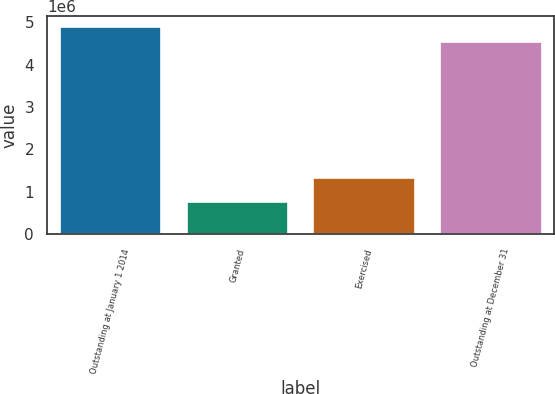Convert chart to OTSL. <chart><loc_0><loc_0><loc_500><loc_500><bar_chart><fcel>Outstanding at January 1 2014<fcel>Granted<fcel>Exercised<fcel>Outstanding at December 31<nl><fcel>4.89155e+06<fcel>771010<fcel>1.31841e+06<fcel>4.53248e+06<nl></chart> 